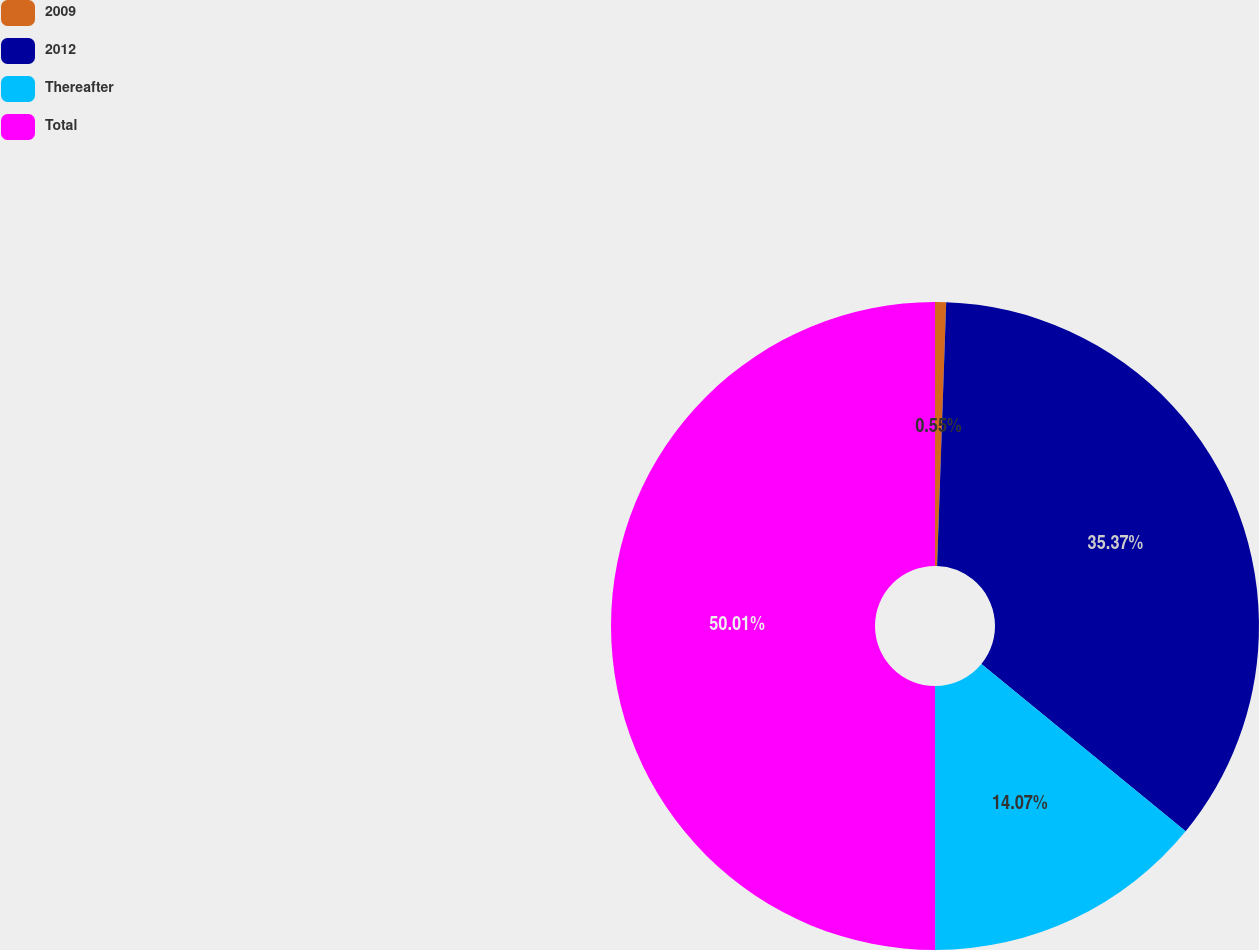<chart> <loc_0><loc_0><loc_500><loc_500><pie_chart><fcel>2009<fcel>2012<fcel>Thereafter<fcel>Total<nl><fcel>0.55%<fcel>35.37%<fcel>14.07%<fcel>50.0%<nl></chart> 